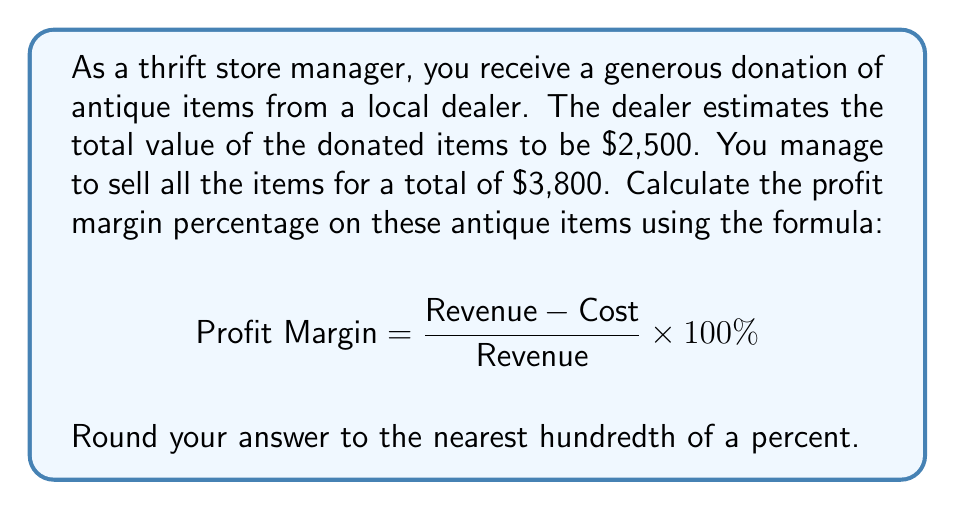Teach me how to tackle this problem. To solve this problem, we need to follow these steps:

1. Identify the given values:
   - Cost (donation value) = $2,500
   - Revenue (selling price) = $3,800

2. Apply the profit margin formula:
   $$ \text{Profit Margin} = \frac{\text{Revenue} - \text{Cost}}{\text{Revenue}} \times 100\% $$

3. Substitute the values into the formula:
   $$ \text{Profit Margin} = \frac{3800 - 2500}{3800} \times 100\% $$

4. Simplify the numerator:
   $$ \text{Profit Margin} = \frac{1300}{3800} \times 100\% $$

5. Perform the division:
   $$ \text{Profit Margin} = 0.3421052631578947 \times 100\% $$

6. Convert to a percentage:
   $$ \text{Profit Margin} = 34.21052631578947\% $$

7. Round to the nearest hundredth of a percent:
   $$ \text{Profit Margin} \approx 34.21\% $$
Answer: 34.21% 